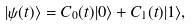<formula> <loc_0><loc_0><loc_500><loc_500>| \psi ( t ) \rangle = C _ { 0 } ( t ) | 0 \rangle + C _ { 1 } ( t ) | 1 \rangle ,</formula> 